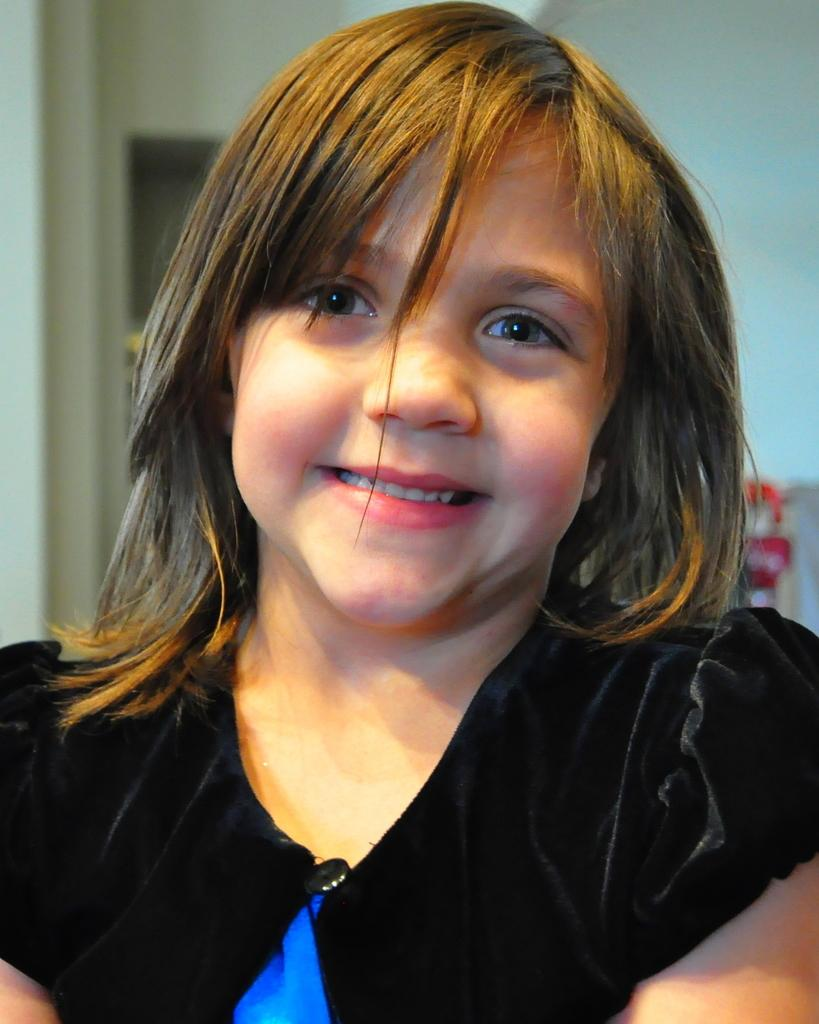Who is the main subject in the image? There is a girl in the image. What is the girl doing in the image? The girl is smiling. What is the girl wearing in the image? The girl is wearing a black dress. What can be seen in the background of the image? There is a wall in the background of the image. What type of robin can be seen in the image? There is no robin present in the image; it features a girl wearing a black dress and smiling. Is the girl eating rice in the image? There is no rice present in the image, and the girl is not shown eating anything. 